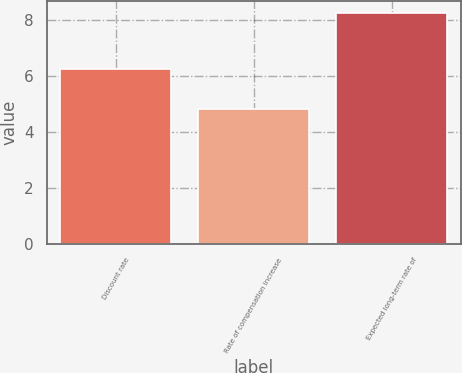Convert chart to OTSL. <chart><loc_0><loc_0><loc_500><loc_500><bar_chart><fcel>Discount rate<fcel>Rate of compensation increase<fcel>Expected long-term rate of<nl><fcel>6.25<fcel>4.8<fcel>8.25<nl></chart> 